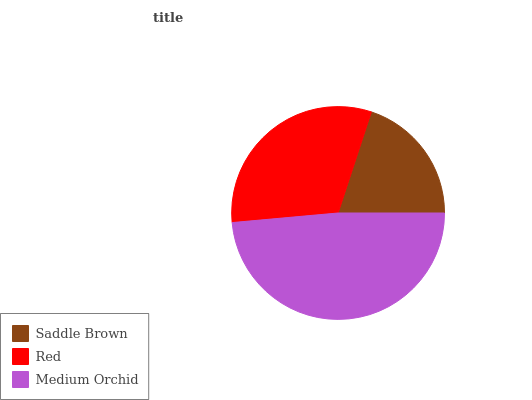Is Saddle Brown the minimum?
Answer yes or no. Yes. Is Medium Orchid the maximum?
Answer yes or no. Yes. Is Red the minimum?
Answer yes or no. No. Is Red the maximum?
Answer yes or no. No. Is Red greater than Saddle Brown?
Answer yes or no. Yes. Is Saddle Brown less than Red?
Answer yes or no. Yes. Is Saddle Brown greater than Red?
Answer yes or no. No. Is Red less than Saddle Brown?
Answer yes or no. No. Is Red the high median?
Answer yes or no. Yes. Is Red the low median?
Answer yes or no. Yes. Is Medium Orchid the high median?
Answer yes or no. No. Is Medium Orchid the low median?
Answer yes or no. No. 